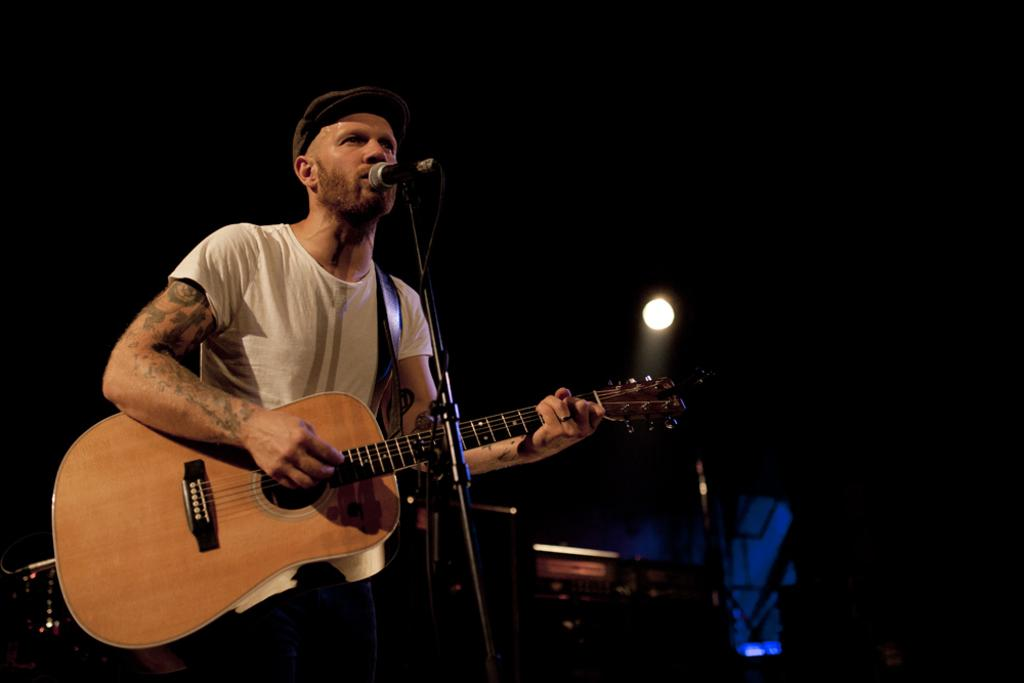What is the person in the image doing? The person is standing, playing the guitar, and singing a song. What object is the person holding in the image? The person is holding a guitar in the image. What accessory is the person wearing in the image? The person is wearing a cap in the image. What can be seen in the background of the image? There are lights and musical instruments visible in the background of the image. What type of offer is the person making to the audience in the image? There is no indication in the image that the person is making any offer to an audience. What time of day is it in the image, considering the presence of lights in the background? The presence of lights in the background does not necessarily indicate the time of day; it could be daytime or nighttime. 